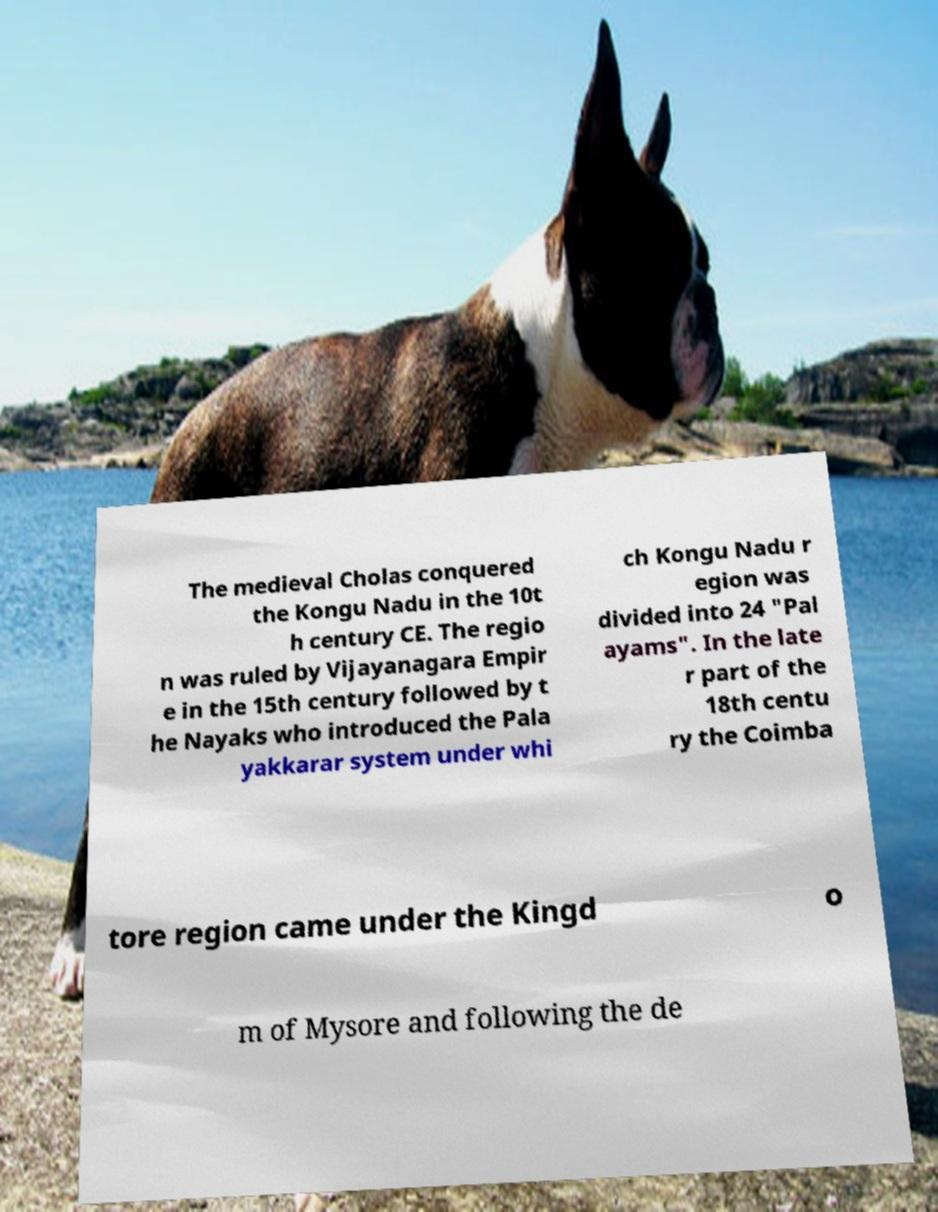I need the written content from this picture converted into text. Can you do that? The medieval Cholas conquered the Kongu Nadu in the 10t h century CE. The regio n was ruled by Vijayanagara Empir e in the 15th century followed by t he Nayaks who introduced the Pala yakkarar system under whi ch Kongu Nadu r egion was divided into 24 "Pal ayams". In the late r part of the 18th centu ry the Coimba tore region came under the Kingd o m of Mysore and following the de 